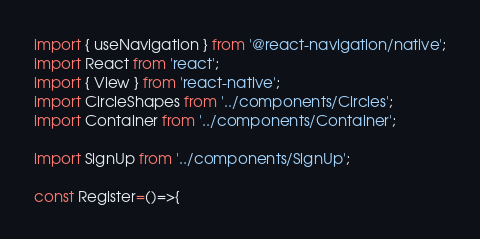Convert code to text. <code><loc_0><loc_0><loc_500><loc_500><_JavaScript_>
import { useNavigation } from '@react-navigation/native';
import React from 'react';
import { View } from 'react-native';
import CircleShapes from '../components/Circles';
import Container from '../components/Container';

import SignUp from '../components/SignUp';

const Register=()=>{</code> 